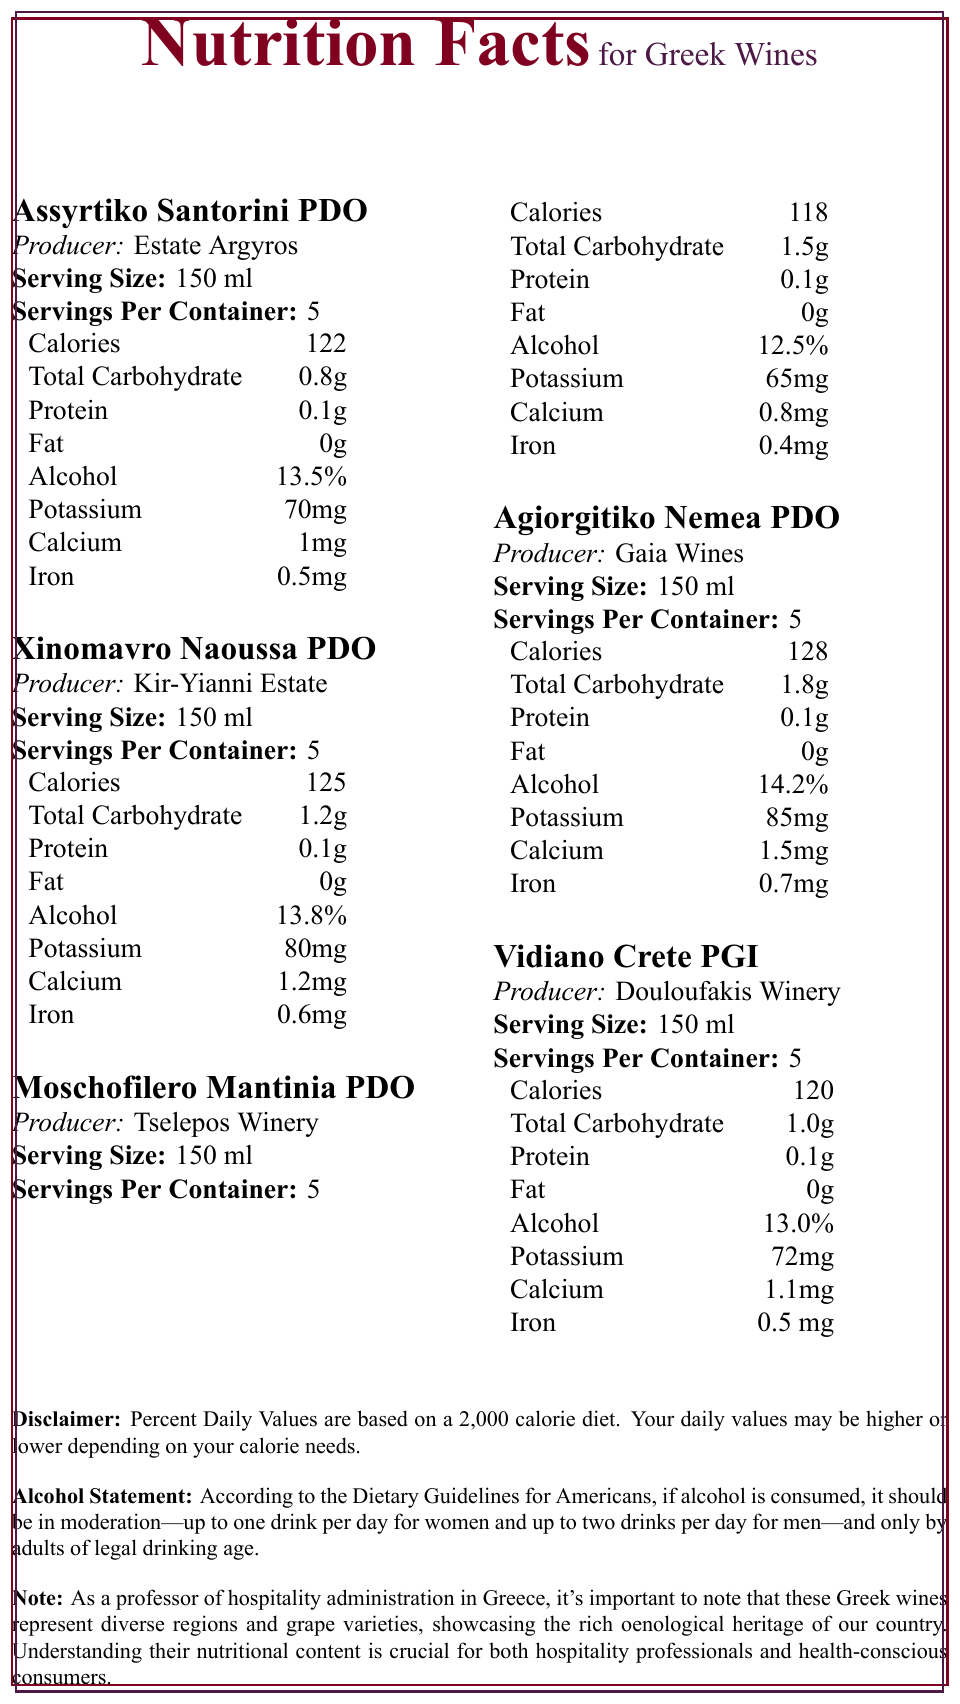What is the serving size for Xinomavro Naoussa PDO? The serving size for each wine, including Xinomavro Naoussa PDO, is listed under the wine's name.
Answer: 150 ml How many calories are in a serving of Moschofilero Mantinia PDO? The calorie content is directly listed under the nutritional information for Moschofilero Mantinia PDO.
Answer: 118 Which wine has the highest alcohol percentage? The alcohol content for Agiorgitiko Nemea PDO is 14.2%, which is the highest among all listed wines.
Answer: Agiorgitiko Nemea PDO How much iron does Vidiano Crete PGI contain per serving? The iron content for each wine is listed in the nutritional information, and Vidiano Crete PGI contains 0.5 mg per serving.
Answer: 0.5 mg How many servings are there in a container for Estate Argyros' Assyrtiko Santorini PDO? Each wine has 5 servings per container as stated in the nutritional information.
Answer: 5 Which wine has the least total carbohydrate content?
A. Assyrtiko Santorini PDO
B. Xinomavro Naoussa PDO
C. Moschofilero Mantinia PDO
D. Agiorgitiko Nemea PDO Assyrtiko Santorini PDO has 0.8 g of total carbohydrates, the least among the listed wines.
Answer: A. Assyrtiko Santorini PDO Which producer's wine contains the highest amount of calcium?
1. Estate Argyros
2. Kir-Yianni Estate
3. Tselepos Winery
4. Gaia Wines
5. Douloufakis Winery Gaia Wines' Agiorgitiko Nemea PDO contains the highest calcium content at 1.5 mg.
Answer: 4. Gaia Wines Does the document specify the percentage of daily values for the nutrients listed in the wines? The document includes a disclaimer that states Percent Daily Values are based on a 2,000 calorie diet but does not give the actual percentage daily values for the wines' nutrients.
Answer: No Summarize the main idea of the document. The summary captures the essence of presenting important nutritional content, relevant disclaimers, and the educational note for a professional context.
Answer: The document provides detailed nutritional information for a selection of Greek wines, highlighting serving size, calorie content, carbohydrate levels, and other nutritional metrics. Additionally, it includes disclaimers about daily values and alcohol consumption guidelines, emphasizing the importance of understanding this information for hospitality professionals and health-conscious consumers. Which wine has the highest calorie content per serving? The document lists Agiorgitiko Nemea PDO as having 128 calories per serving, which is the highest among the listed wines.
Answer: Agiorgitiko Nemea PDO What is the potassium content in the wine produced by Tselepos Winery? Tselepos Winery produces Moschofilero Mantinia PDO, which has a potassium content of 65 mg per serving.
Answer: 65 mg Can you determine the exact harvesting method for these wines from the document? The document only provides nutritional information and does not give any details on the harvesting methods of the wines.
Answer: Not enough information What does the disclaimer in the document state? The disclaimer explains that the Percent Daily Values are based on a 2,000 calorie diet and might vary according to individual calorie needs.
Answer: Percent Daily Values are based on a 2,000 calorie diet. Your daily values may be higher or lower depending on your calorie needs. 